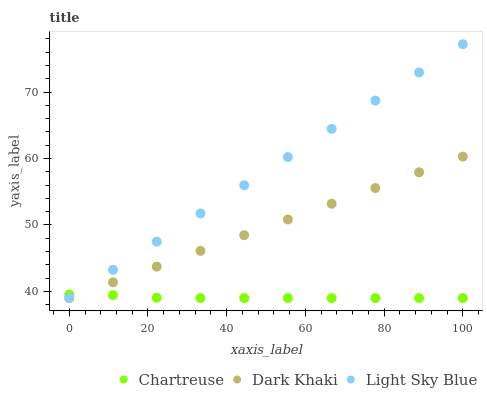Does Chartreuse have the minimum area under the curve?
Answer yes or no. Yes. Does Light Sky Blue have the maximum area under the curve?
Answer yes or no. Yes. Does Light Sky Blue have the minimum area under the curve?
Answer yes or no. No. Does Chartreuse have the maximum area under the curve?
Answer yes or no. No. Is Dark Khaki the smoothest?
Answer yes or no. Yes. Is Chartreuse the roughest?
Answer yes or no. Yes. Is Light Sky Blue the smoothest?
Answer yes or no. No. Is Light Sky Blue the roughest?
Answer yes or no. No. Does Dark Khaki have the lowest value?
Answer yes or no. Yes. Does Light Sky Blue have the highest value?
Answer yes or no. Yes. Does Chartreuse have the highest value?
Answer yes or no. No. Does Dark Khaki intersect Chartreuse?
Answer yes or no. Yes. Is Dark Khaki less than Chartreuse?
Answer yes or no. No. Is Dark Khaki greater than Chartreuse?
Answer yes or no. No. 